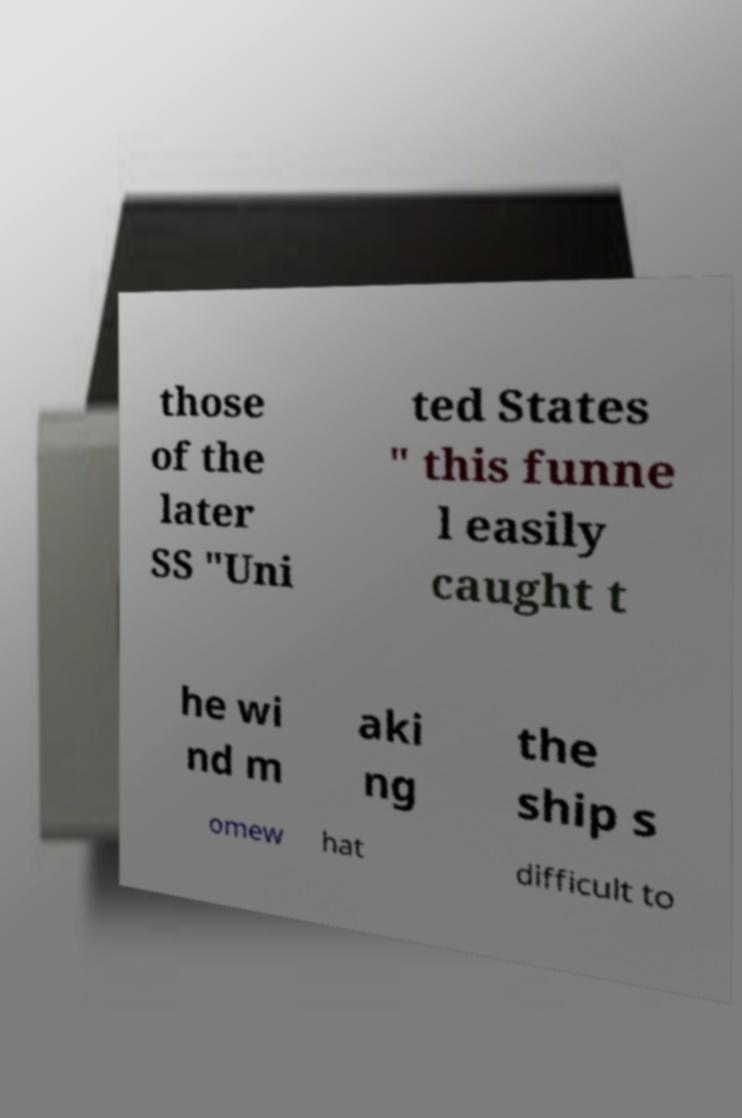Please identify and transcribe the text found in this image. those of the later SS "Uni ted States " this funne l easily caught t he wi nd m aki ng the ship s omew hat difficult to 